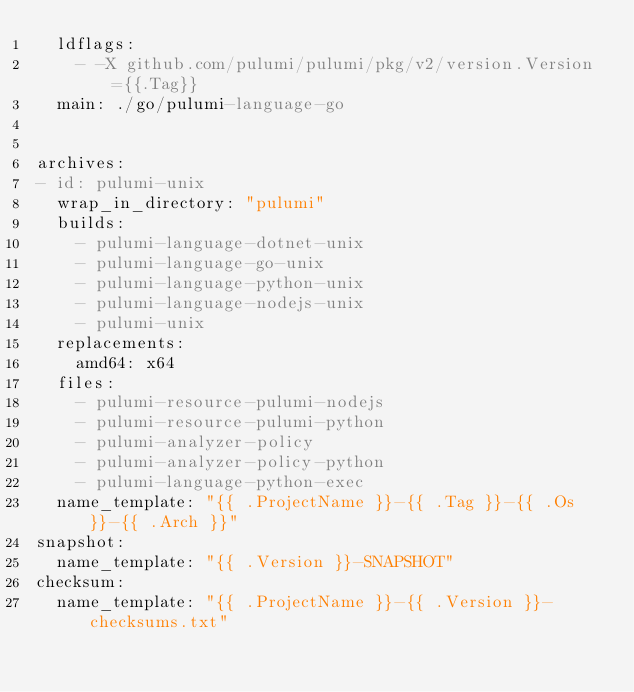Convert code to text. <code><loc_0><loc_0><loc_500><loc_500><_YAML_>  ldflags:
    - -X github.com/pulumi/pulumi/pkg/v2/version.Version={{.Tag}}
  main: ./go/pulumi-language-go


archives:
- id: pulumi-unix
  wrap_in_directory: "pulumi"
  builds:
    - pulumi-language-dotnet-unix
    - pulumi-language-go-unix
    - pulumi-language-python-unix
    - pulumi-language-nodejs-unix
    - pulumi-unix
  replacements:
    amd64: x64
  files:
    - pulumi-resource-pulumi-nodejs
    - pulumi-resource-pulumi-python
    - pulumi-analyzer-policy
    - pulumi-analyzer-policy-python
    - pulumi-language-python-exec
  name_template: "{{ .ProjectName }}-{{ .Tag }}-{{ .Os }}-{{ .Arch }}"
snapshot:
  name_template: "{{ .Version }}-SNAPSHOT"
checksum: 
  name_template: "{{ .ProjectName }}-{{ .Version }}-checksums.txt"
</code> 